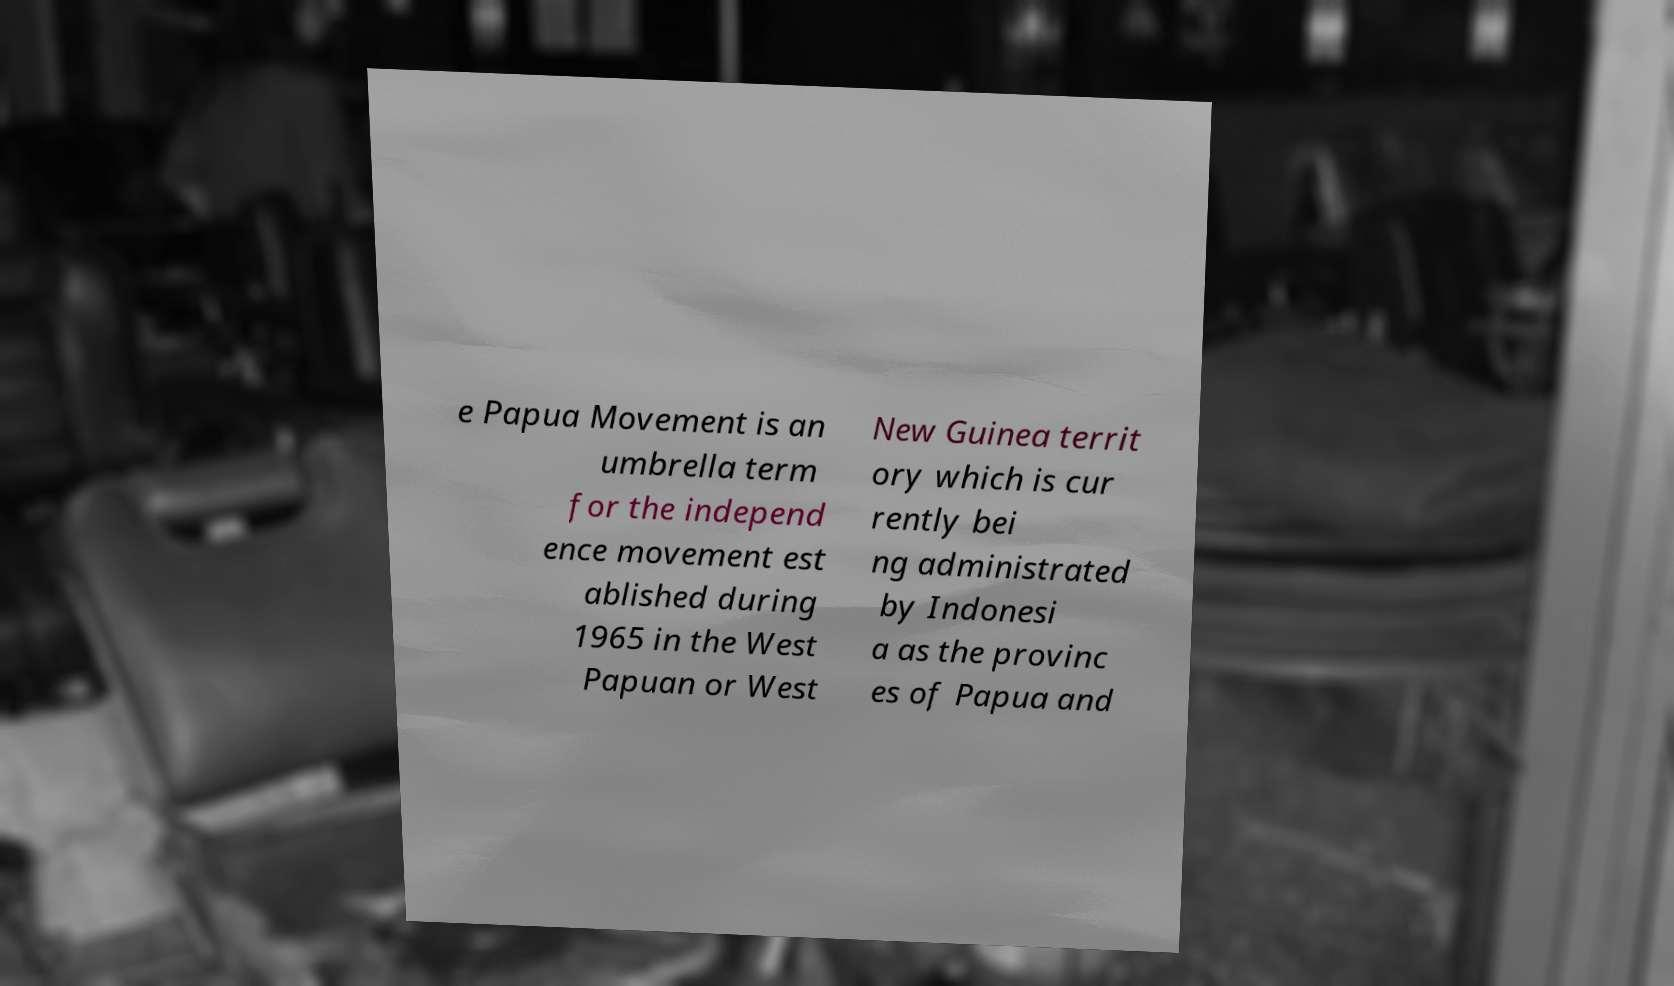Could you extract and type out the text from this image? e Papua Movement is an umbrella term for the independ ence movement est ablished during 1965 in the West Papuan or West New Guinea territ ory which is cur rently bei ng administrated by Indonesi a as the provinc es of Papua and 